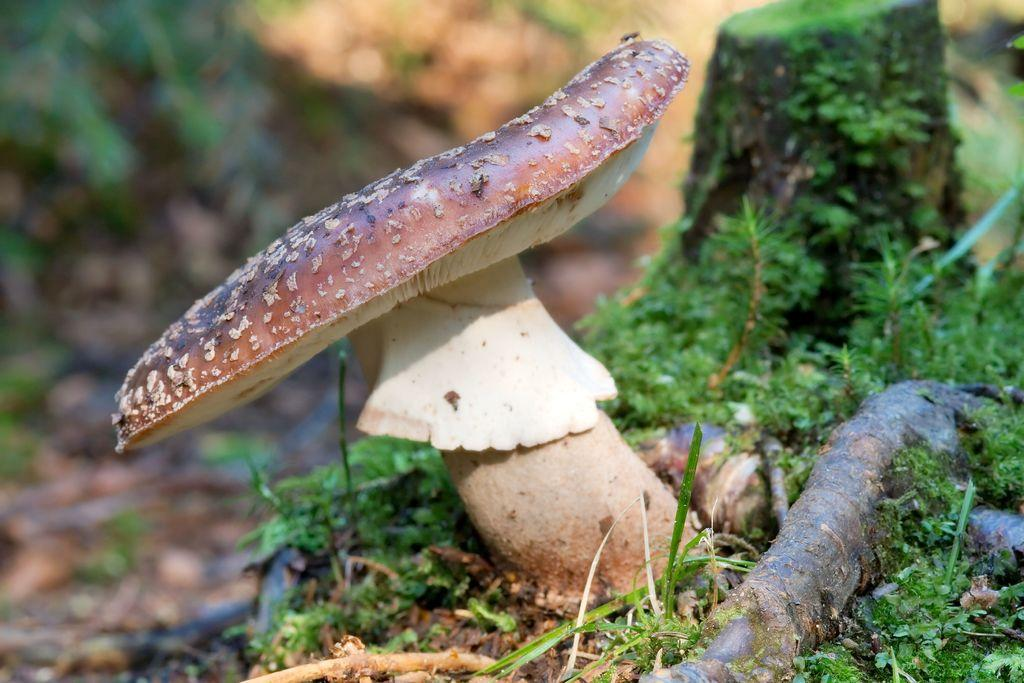What is the main subject of the image? There is a mushroom in the image. Can you describe the colors of the mushroom? The mushroom has brown and cream colors. What can be seen in the background of the image? There are plants in the background of the image. What color are the plants in the image? The plants have green colors. What type of sponge is being used to clean the lamp in the image? There is no sponge or lamp present in the image; it only features a mushroom and plants in the background. 